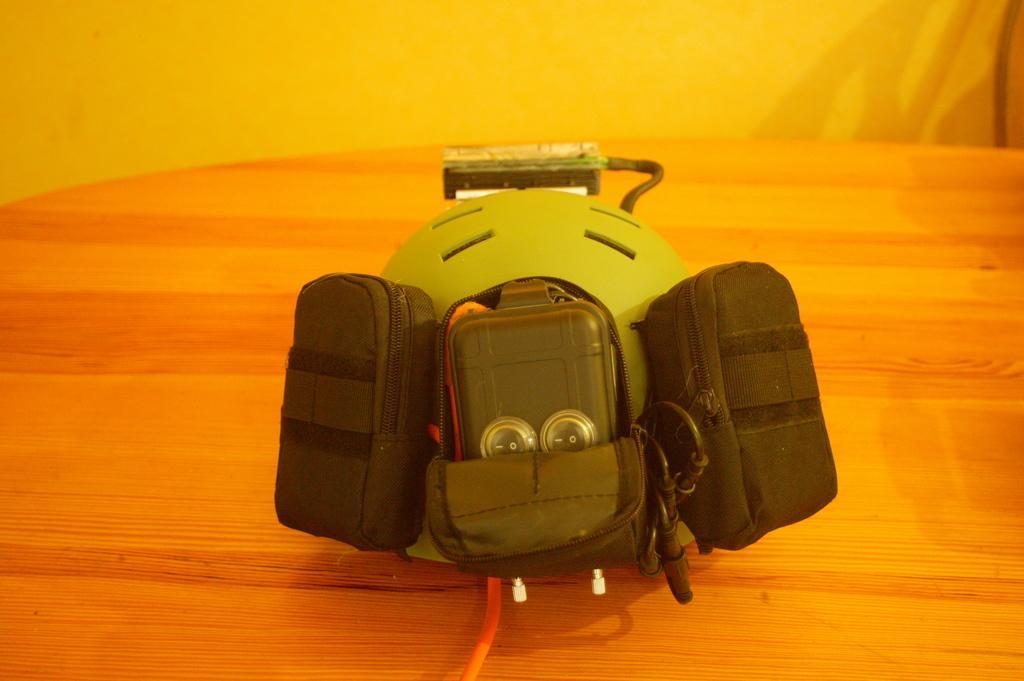Please provide a concise description of this image. This picture shows a toy on the table 